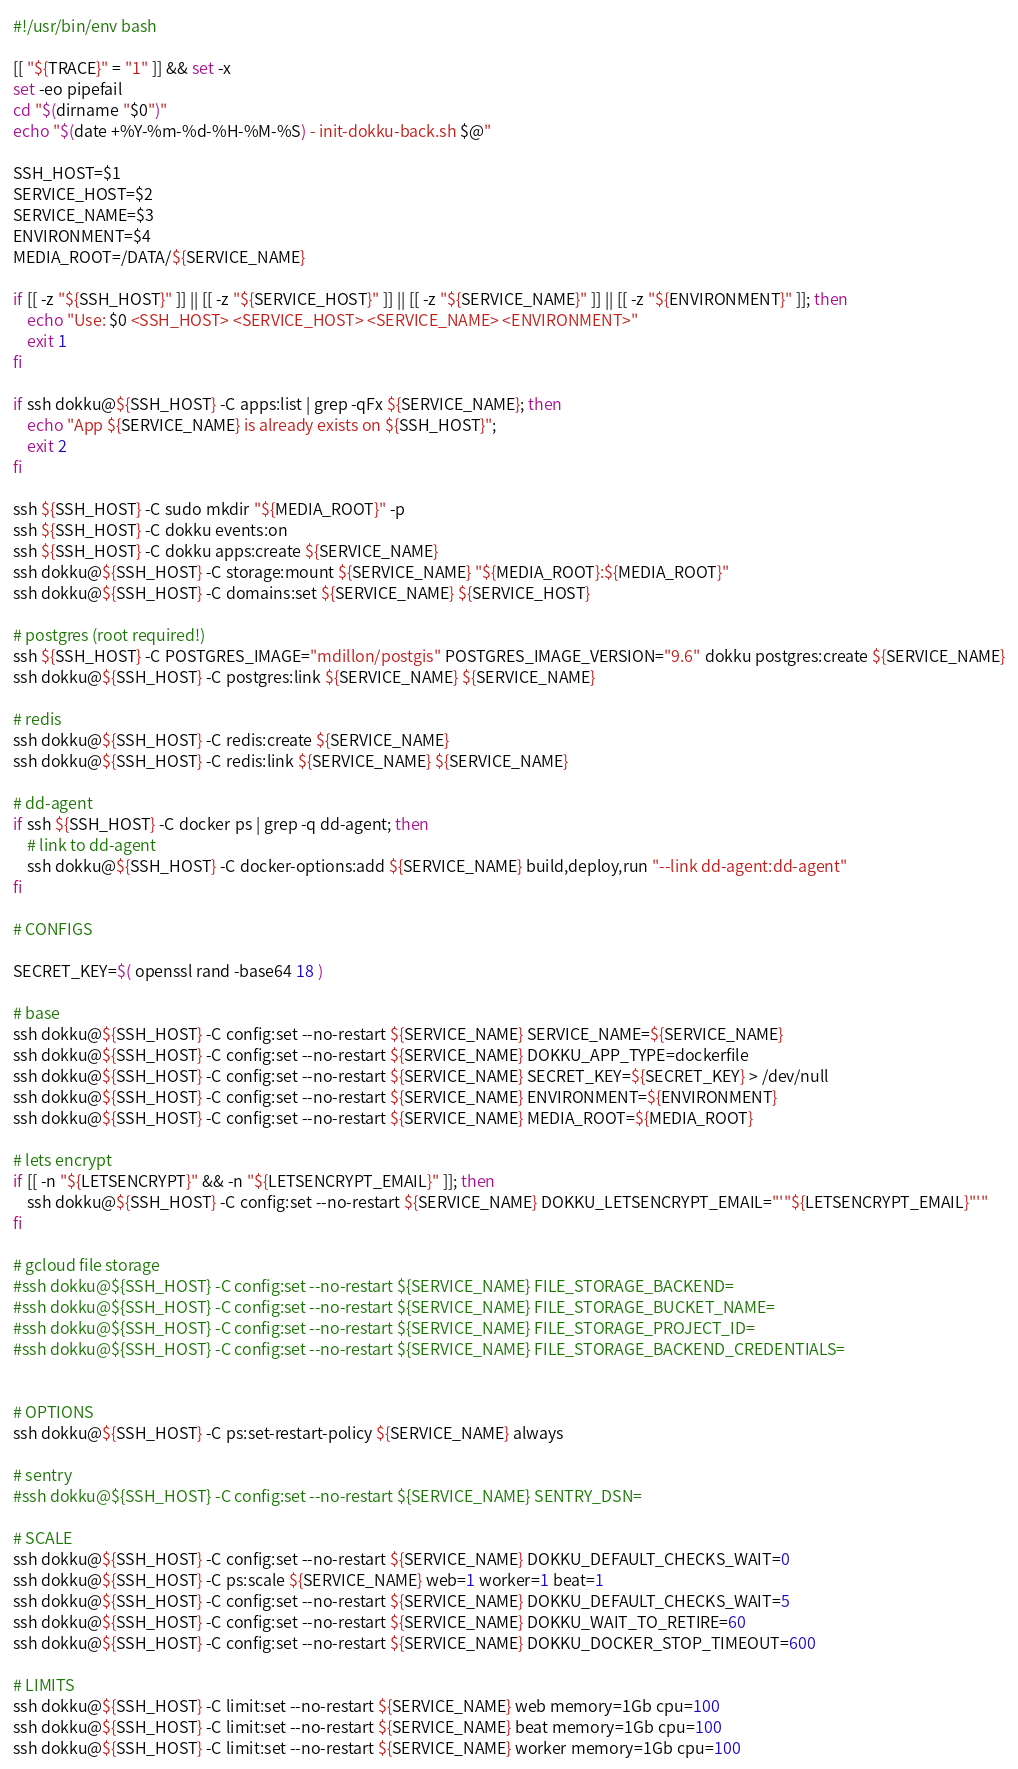<code> <loc_0><loc_0><loc_500><loc_500><_Bash_>#!/usr/bin/env bash

[[ "${TRACE}" = "1" ]] && set -x
set -eo pipefail
cd "$(dirname "$0")"
echo "$(date +%Y-%m-%d-%H-%M-%S) - init-dokku-back.sh $@"

SSH_HOST=$1
SERVICE_HOST=$2
SERVICE_NAME=$3
ENVIRONMENT=$4
MEDIA_ROOT=/DATA/${SERVICE_NAME}

if [[ -z "${SSH_HOST}" ]] || [[ -z "${SERVICE_HOST}" ]] || [[ -z "${SERVICE_NAME}" ]] || [[ -z "${ENVIRONMENT}" ]]; then
    echo "Use: $0 <SSH_HOST> <SERVICE_HOST> <SERVICE_NAME> <ENVIRONMENT>"
    exit 1
fi

if ssh dokku@${SSH_HOST} -C apps:list | grep -qFx ${SERVICE_NAME}; then
    echo "App ${SERVICE_NAME} is already exists on ${SSH_HOST}";
    exit 2
fi

ssh ${SSH_HOST} -C sudo mkdir "${MEDIA_ROOT}" -p
ssh ${SSH_HOST} -C dokku events:on
ssh ${SSH_HOST} -C dokku apps:create ${SERVICE_NAME}
ssh dokku@${SSH_HOST} -C storage:mount ${SERVICE_NAME} "${MEDIA_ROOT}:${MEDIA_ROOT}"
ssh dokku@${SSH_HOST} -C domains:set ${SERVICE_NAME} ${SERVICE_HOST}

# postgres (root required!)
ssh ${SSH_HOST} -C POSTGRES_IMAGE="mdillon/postgis" POSTGRES_IMAGE_VERSION="9.6" dokku postgres:create ${SERVICE_NAME}
ssh dokku@${SSH_HOST} -C postgres:link ${SERVICE_NAME} ${SERVICE_NAME}

# redis
ssh dokku@${SSH_HOST} -C redis:create ${SERVICE_NAME}
ssh dokku@${SSH_HOST} -C redis:link ${SERVICE_NAME} ${SERVICE_NAME}

# dd-agent
if ssh ${SSH_HOST} -C docker ps | grep -q dd-agent; then
    # link to dd-agent
    ssh dokku@${SSH_HOST} -C docker-options:add ${SERVICE_NAME} build,deploy,run "--link dd-agent:dd-agent"
fi

# CONFIGS

SECRET_KEY=$( openssl rand -base64 18 )

# base
ssh dokku@${SSH_HOST} -C config:set --no-restart ${SERVICE_NAME} SERVICE_NAME=${SERVICE_NAME}
ssh dokku@${SSH_HOST} -C config:set --no-restart ${SERVICE_NAME} DOKKU_APP_TYPE=dockerfile
ssh dokku@${SSH_HOST} -C config:set --no-restart ${SERVICE_NAME} SECRET_KEY=${SECRET_KEY} > /dev/null
ssh dokku@${SSH_HOST} -C config:set --no-restart ${SERVICE_NAME} ENVIRONMENT=${ENVIRONMENT}
ssh dokku@${SSH_HOST} -C config:set --no-restart ${SERVICE_NAME} MEDIA_ROOT=${MEDIA_ROOT}

# lets encrypt
if [[ -n "${LETSENCRYPT}" && -n "${LETSENCRYPT_EMAIL}" ]]; then
    ssh dokku@${SSH_HOST} -C config:set --no-restart ${SERVICE_NAME} DOKKU_LETSENCRYPT_EMAIL="'"${LETSENCRYPT_EMAIL}"'"
fi

# gcloud file storage
#ssh dokku@${SSH_HOST} -C config:set --no-restart ${SERVICE_NAME} FILE_STORAGE_BACKEND=
#ssh dokku@${SSH_HOST} -C config:set --no-restart ${SERVICE_NAME} FILE_STORAGE_BUCKET_NAME=
#ssh dokku@${SSH_HOST} -C config:set --no-restart ${SERVICE_NAME} FILE_STORAGE_PROJECT_ID=
#ssh dokku@${SSH_HOST} -C config:set --no-restart ${SERVICE_NAME} FILE_STORAGE_BACKEND_CREDENTIALS=


# OPTIONS
ssh dokku@${SSH_HOST} -C ps:set-restart-policy ${SERVICE_NAME} always

# sentry
#ssh dokku@${SSH_HOST} -C config:set --no-restart ${SERVICE_NAME} SENTRY_DSN=

# SCALE
ssh dokku@${SSH_HOST} -C config:set --no-restart ${SERVICE_NAME} DOKKU_DEFAULT_CHECKS_WAIT=0
ssh dokku@${SSH_HOST} -C ps:scale ${SERVICE_NAME} web=1 worker=1 beat=1
ssh dokku@${SSH_HOST} -C config:set --no-restart ${SERVICE_NAME} DOKKU_DEFAULT_CHECKS_WAIT=5
ssh dokku@${SSH_HOST} -C config:set --no-restart ${SERVICE_NAME} DOKKU_WAIT_TO_RETIRE=60
ssh dokku@${SSH_HOST} -C config:set --no-restart ${SERVICE_NAME} DOKKU_DOCKER_STOP_TIMEOUT=600

# LIMITS
ssh dokku@${SSH_HOST} -C limit:set --no-restart ${SERVICE_NAME} web memory=1Gb cpu=100
ssh dokku@${SSH_HOST} -C limit:set --no-restart ${SERVICE_NAME} beat memory=1Gb cpu=100
ssh dokku@${SSH_HOST} -C limit:set --no-restart ${SERVICE_NAME} worker memory=1Gb cpu=100
</code> 